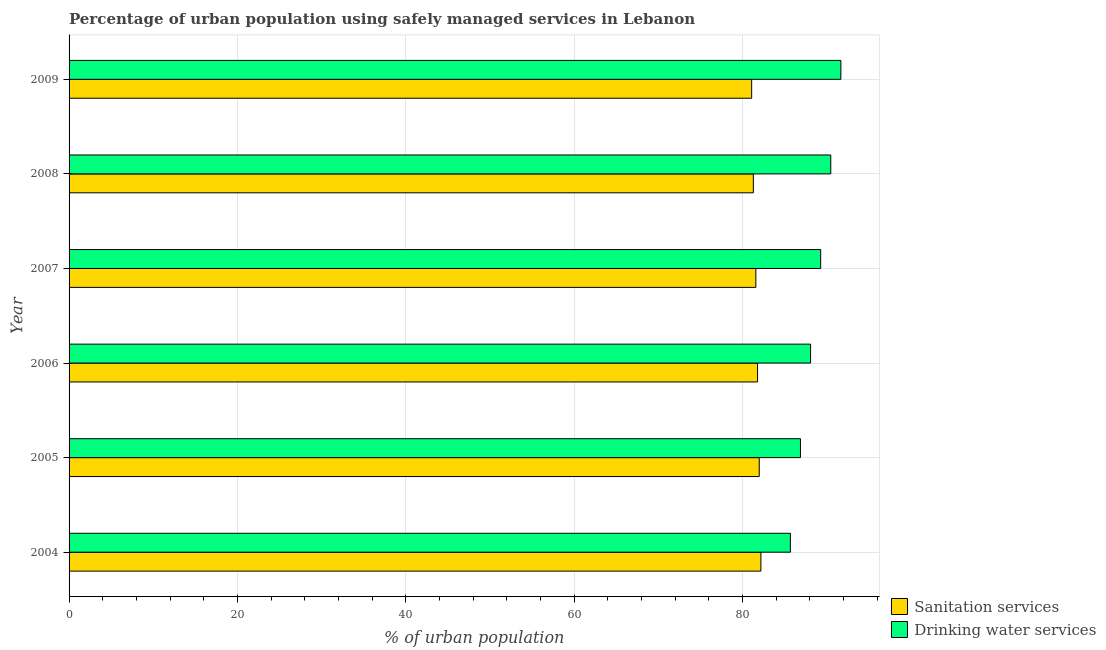How many different coloured bars are there?
Make the answer very short. 2. Are the number of bars per tick equal to the number of legend labels?
Provide a succinct answer. Yes. Are the number of bars on each tick of the Y-axis equal?
Give a very brief answer. Yes. How many bars are there on the 5th tick from the top?
Provide a short and direct response. 2. How many bars are there on the 4th tick from the bottom?
Make the answer very short. 2. What is the label of the 6th group of bars from the top?
Ensure brevity in your answer.  2004. In how many cases, is the number of bars for a given year not equal to the number of legend labels?
Keep it short and to the point. 0. What is the percentage of urban population who used drinking water services in 2006?
Give a very brief answer. 88.1. Across all years, what is the maximum percentage of urban population who used drinking water services?
Keep it short and to the point. 91.7. Across all years, what is the minimum percentage of urban population who used drinking water services?
Offer a very short reply. 85.7. In which year was the percentage of urban population who used sanitation services maximum?
Keep it short and to the point. 2004. In which year was the percentage of urban population who used sanitation services minimum?
Offer a very short reply. 2009. What is the total percentage of urban population who used sanitation services in the graph?
Give a very brief answer. 490. What is the difference between the percentage of urban population who used sanitation services in 2005 and the percentage of urban population who used drinking water services in 2007?
Ensure brevity in your answer.  -7.3. What is the average percentage of urban population who used drinking water services per year?
Provide a succinct answer. 88.7. What is the ratio of the percentage of urban population who used drinking water services in 2007 to that in 2008?
Provide a succinct answer. 0.99. Is the percentage of urban population who used drinking water services in 2005 less than that in 2008?
Your answer should be very brief. Yes. Is the difference between the percentage of urban population who used drinking water services in 2006 and 2008 greater than the difference between the percentage of urban population who used sanitation services in 2006 and 2008?
Provide a succinct answer. No. What is the difference between the highest and the second highest percentage of urban population who used drinking water services?
Make the answer very short. 1.2. What is the difference between the highest and the lowest percentage of urban population who used sanitation services?
Offer a terse response. 1.1. What does the 1st bar from the top in 2005 represents?
Provide a succinct answer. Drinking water services. What does the 2nd bar from the bottom in 2008 represents?
Your answer should be very brief. Drinking water services. How many bars are there?
Give a very brief answer. 12. Are all the bars in the graph horizontal?
Your response must be concise. Yes. Does the graph contain any zero values?
Provide a short and direct response. No. How many legend labels are there?
Keep it short and to the point. 2. How are the legend labels stacked?
Make the answer very short. Vertical. What is the title of the graph?
Your answer should be very brief. Percentage of urban population using safely managed services in Lebanon. Does "Under-5(female)" appear as one of the legend labels in the graph?
Ensure brevity in your answer.  No. What is the label or title of the X-axis?
Your answer should be very brief. % of urban population. What is the label or title of the Y-axis?
Provide a succinct answer. Year. What is the % of urban population in Sanitation services in 2004?
Keep it short and to the point. 82.2. What is the % of urban population in Drinking water services in 2004?
Your answer should be very brief. 85.7. What is the % of urban population of Drinking water services in 2005?
Your answer should be compact. 86.9. What is the % of urban population in Sanitation services in 2006?
Provide a succinct answer. 81.8. What is the % of urban population of Drinking water services in 2006?
Keep it short and to the point. 88.1. What is the % of urban population of Sanitation services in 2007?
Keep it short and to the point. 81.6. What is the % of urban population in Drinking water services in 2007?
Make the answer very short. 89.3. What is the % of urban population in Sanitation services in 2008?
Offer a terse response. 81.3. What is the % of urban population of Drinking water services in 2008?
Ensure brevity in your answer.  90.5. What is the % of urban population in Sanitation services in 2009?
Provide a succinct answer. 81.1. What is the % of urban population of Drinking water services in 2009?
Offer a very short reply. 91.7. Across all years, what is the maximum % of urban population in Sanitation services?
Your answer should be compact. 82.2. Across all years, what is the maximum % of urban population in Drinking water services?
Offer a very short reply. 91.7. Across all years, what is the minimum % of urban population of Sanitation services?
Offer a terse response. 81.1. Across all years, what is the minimum % of urban population of Drinking water services?
Offer a terse response. 85.7. What is the total % of urban population in Sanitation services in the graph?
Your response must be concise. 490. What is the total % of urban population in Drinking water services in the graph?
Offer a terse response. 532.2. What is the difference between the % of urban population of Sanitation services in 2004 and that in 2005?
Provide a short and direct response. 0.2. What is the difference between the % of urban population in Drinking water services in 2004 and that in 2005?
Your answer should be compact. -1.2. What is the difference between the % of urban population in Sanitation services in 2004 and that in 2006?
Your answer should be compact. 0.4. What is the difference between the % of urban population of Drinking water services in 2004 and that in 2006?
Ensure brevity in your answer.  -2.4. What is the difference between the % of urban population of Sanitation services in 2004 and that in 2008?
Provide a succinct answer. 0.9. What is the difference between the % of urban population of Sanitation services in 2004 and that in 2009?
Your answer should be very brief. 1.1. What is the difference between the % of urban population of Drinking water services in 2005 and that in 2006?
Offer a very short reply. -1.2. What is the difference between the % of urban population in Drinking water services in 2005 and that in 2007?
Provide a succinct answer. -2.4. What is the difference between the % of urban population in Sanitation services in 2005 and that in 2009?
Offer a very short reply. 0.9. What is the difference between the % of urban population of Drinking water services in 2005 and that in 2009?
Keep it short and to the point. -4.8. What is the difference between the % of urban population in Sanitation services in 2006 and that in 2007?
Your answer should be compact. 0.2. What is the difference between the % of urban population of Sanitation services in 2006 and that in 2008?
Ensure brevity in your answer.  0.5. What is the difference between the % of urban population in Drinking water services in 2006 and that in 2008?
Make the answer very short. -2.4. What is the difference between the % of urban population in Sanitation services in 2006 and that in 2009?
Keep it short and to the point. 0.7. What is the difference between the % of urban population in Sanitation services in 2007 and that in 2008?
Offer a very short reply. 0.3. What is the difference between the % of urban population in Drinking water services in 2008 and that in 2009?
Your response must be concise. -1.2. What is the difference between the % of urban population in Sanitation services in 2005 and the % of urban population in Drinking water services in 2006?
Your response must be concise. -6.1. What is the difference between the % of urban population in Sanitation services in 2005 and the % of urban population in Drinking water services in 2008?
Your answer should be compact. -8.5. What is the difference between the % of urban population in Sanitation services in 2006 and the % of urban population in Drinking water services in 2007?
Give a very brief answer. -7.5. What is the difference between the % of urban population of Sanitation services in 2006 and the % of urban population of Drinking water services in 2009?
Keep it short and to the point. -9.9. What is the difference between the % of urban population in Sanitation services in 2007 and the % of urban population in Drinking water services in 2008?
Keep it short and to the point. -8.9. What is the difference between the % of urban population in Sanitation services in 2007 and the % of urban population in Drinking water services in 2009?
Keep it short and to the point. -10.1. What is the average % of urban population of Sanitation services per year?
Provide a short and direct response. 81.67. What is the average % of urban population of Drinking water services per year?
Provide a short and direct response. 88.7. In the year 2005, what is the difference between the % of urban population of Sanitation services and % of urban population of Drinking water services?
Offer a very short reply. -4.9. In the year 2006, what is the difference between the % of urban population in Sanitation services and % of urban population in Drinking water services?
Offer a terse response. -6.3. In the year 2007, what is the difference between the % of urban population of Sanitation services and % of urban population of Drinking water services?
Your answer should be very brief. -7.7. In the year 2008, what is the difference between the % of urban population of Sanitation services and % of urban population of Drinking water services?
Keep it short and to the point. -9.2. What is the ratio of the % of urban population in Sanitation services in 2004 to that in 2005?
Your answer should be compact. 1. What is the ratio of the % of urban population in Drinking water services in 2004 to that in 2005?
Make the answer very short. 0.99. What is the ratio of the % of urban population of Drinking water services in 2004 to that in 2006?
Ensure brevity in your answer.  0.97. What is the ratio of the % of urban population in Sanitation services in 2004 to that in 2007?
Provide a succinct answer. 1.01. What is the ratio of the % of urban population in Drinking water services in 2004 to that in 2007?
Provide a short and direct response. 0.96. What is the ratio of the % of urban population in Sanitation services in 2004 to that in 2008?
Offer a very short reply. 1.01. What is the ratio of the % of urban population of Drinking water services in 2004 to that in 2008?
Your answer should be compact. 0.95. What is the ratio of the % of urban population in Sanitation services in 2004 to that in 2009?
Offer a terse response. 1.01. What is the ratio of the % of urban population of Drinking water services in 2004 to that in 2009?
Make the answer very short. 0.93. What is the ratio of the % of urban population of Drinking water services in 2005 to that in 2006?
Your answer should be very brief. 0.99. What is the ratio of the % of urban population in Drinking water services in 2005 to that in 2007?
Ensure brevity in your answer.  0.97. What is the ratio of the % of urban population in Sanitation services in 2005 to that in 2008?
Keep it short and to the point. 1.01. What is the ratio of the % of urban population in Drinking water services in 2005 to that in 2008?
Offer a terse response. 0.96. What is the ratio of the % of urban population of Sanitation services in 2005 to that in 2009?
Offer a terse response. 1.01. What is the ratio of the % of urban population in Drinking water services in 2005 to that in 2009?
Provide a short and direct response. 0.95. What is the ratio of the % of urban population in Sanitation services in 2006 to that in 2007?
Provide a succinct answer. 1. What is the ratio of the % of urban population in Drinking water services in 2006 to that in 2007?
Your answer should be compact. 0.99. What is the ratio of the % of urban population of Sanitation services in 2006 to that in 2008?
Your answer should be compact. 1.01. What is the ratio of the % of urban population in Drinking water services in 2006 to that in 2008?
Provide a short and direct response. 0.97. What is the ratio of the % of urban population of Sanitation services in 2006 to that in 2009?
Keep it short and to the point. 1.01. What is the ratio of the % of urban population in Drinking water services in 2006 to that in 2009?
Your answer should be compact. 0.96. What is the ratio of the % of urban population in Sanitation services in 2007 to that in 2008?
Ensure brevity in your answer.  1. What is the ratio of the % of urban population of Drinking water services in 2007 to that in 2008?
Make the answer very short. 0.99. What is the ratio of the % of urban population in Drinking water services in 2007 to that in 2009?
Provide a short and direct response. 0.97. What is the ratio of the % of urban population of Sanitation services in 2008 to that in 2009?
Keep it short and to the point. 1. What is the ratio of the % of urban population in Drinking water services in 2008 to that in 2009?
Your answer should be very brief. 0.99. What is the difference between the highest and the second highest % of urban population of Sanitation services?
Your answer should be compact. 0.2. What is the difference between the highest and the lowest % of urban population of Sanitation services?
Provide a short and direct response. 1.1. What is the difference between the highest and the lowest % of urban population of Drinking water services?
Offer a terse response. 6. 